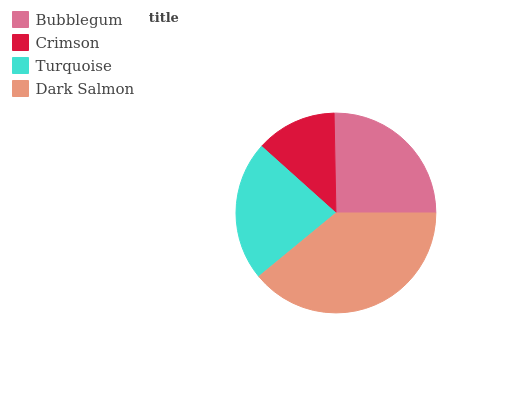Is Crimson the minimum?
Answer yes or no. Yes. Is Dark Salmon the maximum?
Answer yes or no. Yes. Is Turquoise the minimum?
Answer yes or no. No. Is Turquoise the maximum?
Answer yes or no. No. Is Turquoise greater than Crimson?
Answer yes or no. Yes. Is Crimson less than Turquoise?
Answer yes or no. Yes. Is Crimson greater than Turquoise?
Answer yes or no. No. Is Turquoise less than Crimson?
Answer yes or no. No. Is Bubblegum the high median?
Answer yes or no. Yes. Is Turquoise the low median?
Answer yes or no. Yes. Is Crimson the high median?
Answer yes or no. No. Is Bubblegum the low median?
Answer yes or no. No. 